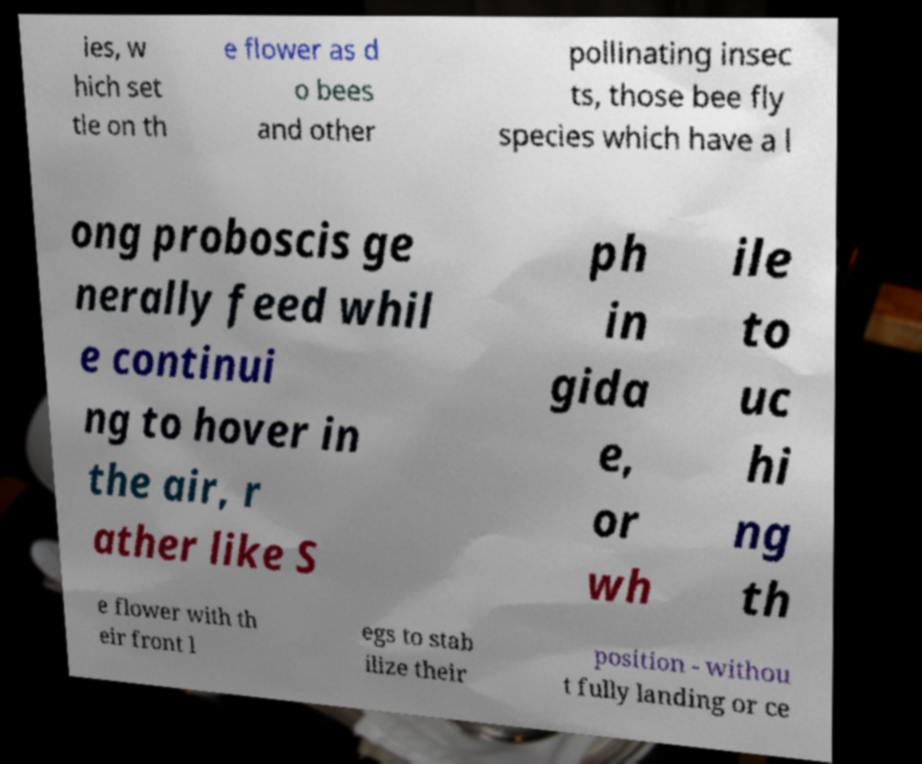Can you read and provide the text displayed in the image?This photo seems to have some interesting text. Can you extract and type it out for me? ies, w hich set tle on th e flower as d o bees and other pollinating insec ts, those bee fly species which have a l ong proboscis ge nerally feed whil e continui ng to hover in the air, r ather like S ph in gida e, or wh ile to uc hi ng th e flower with th eir front l egs to stab ilize their position - withou t fully landing or ce 